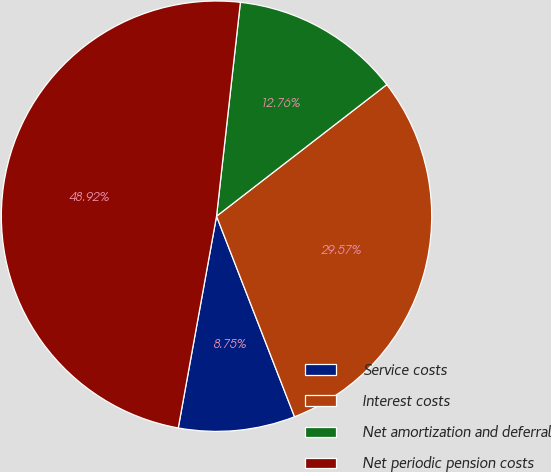<chart> <loc_0><loc_0><loc_500><loc_500><pie_chart><fcel>Service costs<fcel>Interest costs<fcel>Net amortization and deferral<fcel>Net periodic pension costs<nl><fcel>8.75%<fcel>29.57%<fcel>12.76%<fcel>48.92%<nl></chart> 